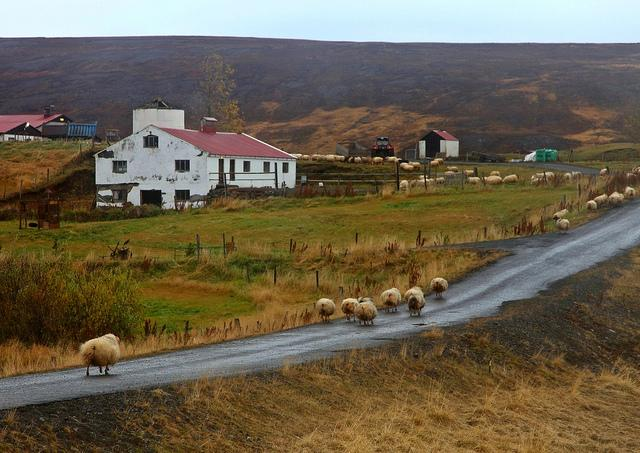What has caused the road to look slick?

Choices:
A) snow
B) rain
C) ice
D) wax rain 